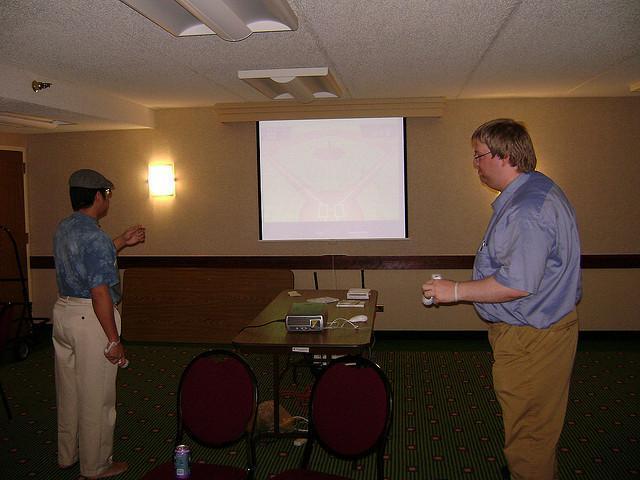How many people are standing?
Give a very brief answer. 2. How many people are in the room?
Give a very brief answer. 2. How many people are there?
Give a very brief answer. 2. How many chairs can you see?
Give a very brief answer. 2. How many bears are wearing a cap?
Give a very brief answer. 0. 